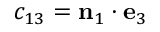Convert formula to latex. <formula><loc_0><loc_0><loc_500><loc_500>c _ { 1 3 } = n _ { 1 } \cdot e _ { 3 }</formula> 